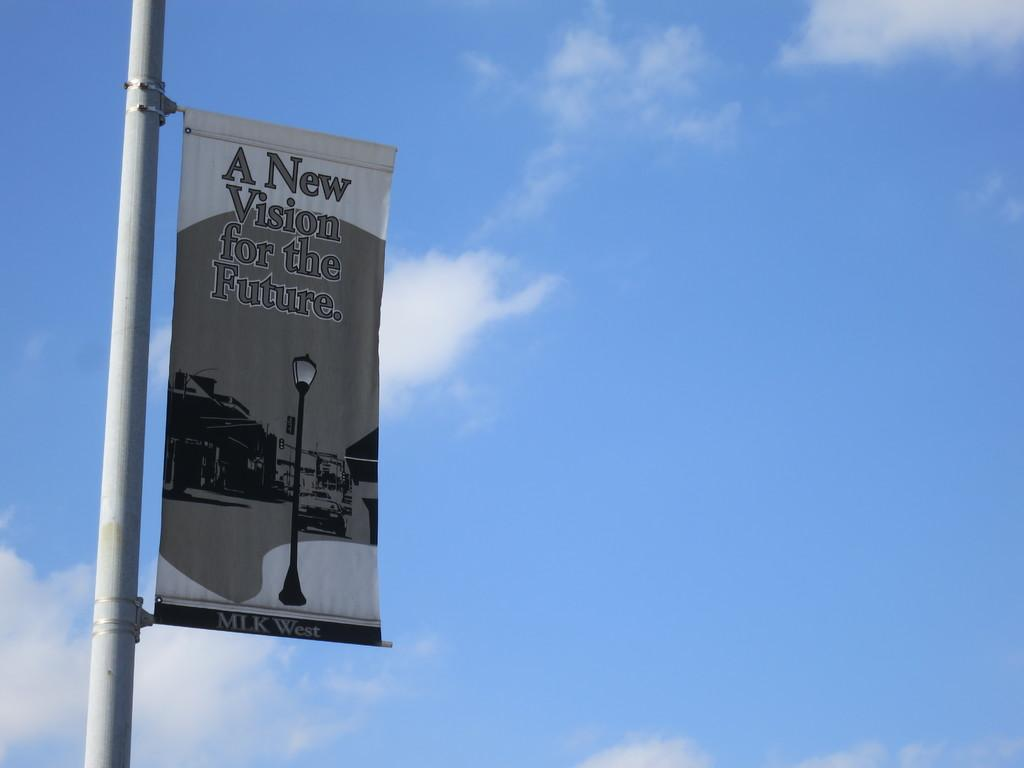<image>
Write a terse but informative summary of the picture. A tarpaulin with a message "A new Vision for the Future". 